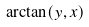<formula> <loc_0><loc_0><loc_500><loc_500>\arctan ( y , x )</formula> 